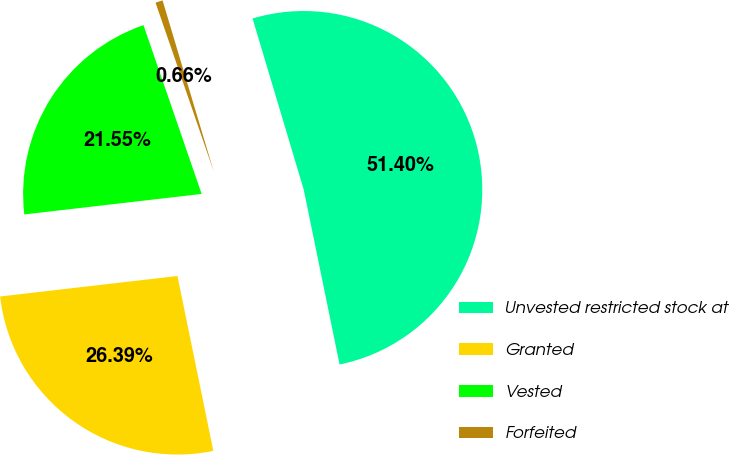Convert chart. <chart><loc_0><loc_0><loc_500><loc_500><pie_chart><fcel>Unvested restricted stock at<fcel>Granted<fcel>Vested<fcel>Forfeited<nl><fcel>51.41%<fcel>26.39%<fcel>21.55%<fcel>0.66%<nl></chart> 